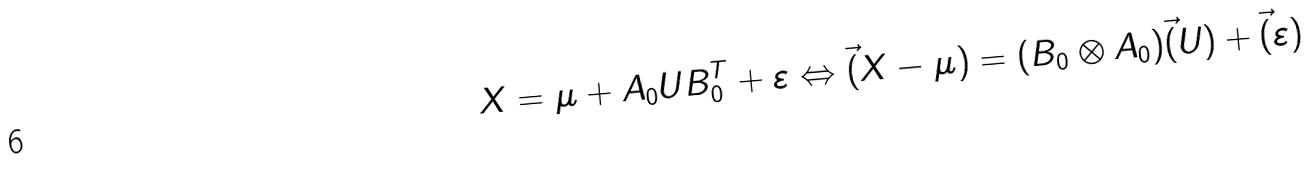Convert formula to latex. <formula><loc_0><loc_0><loc_500><loc_500>X = \mu + A _ { 0 } U B _ { 0 } ^ { T } + \varepsilon \Leftrightarrow \vec { ( } X - \mu ) = ( B _ { 0 } \otimes A _ { 0 } ) \vec { ( } U ) + \vec { ( } \varepsilon )</formula> 